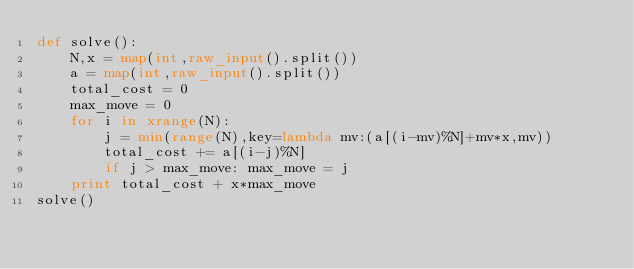Convert code to text. <code><loc_0><loc_0><loc_500><loc_500><_Python_>def solve():
	N,x = map(int,raw_input().split())
	a = map(int,raw_input().split())
	total_cost = 0
	max_move = 0
	for i in xrange(N):
		j = min(range(N),key=lambda mv:(a[(i-mv)%N]+mv*x,mv))
		total_cost += a[(i-j)%N]
		if j > max_move: max_move = j
	print total_cost + x*max_move
solve()</code> 